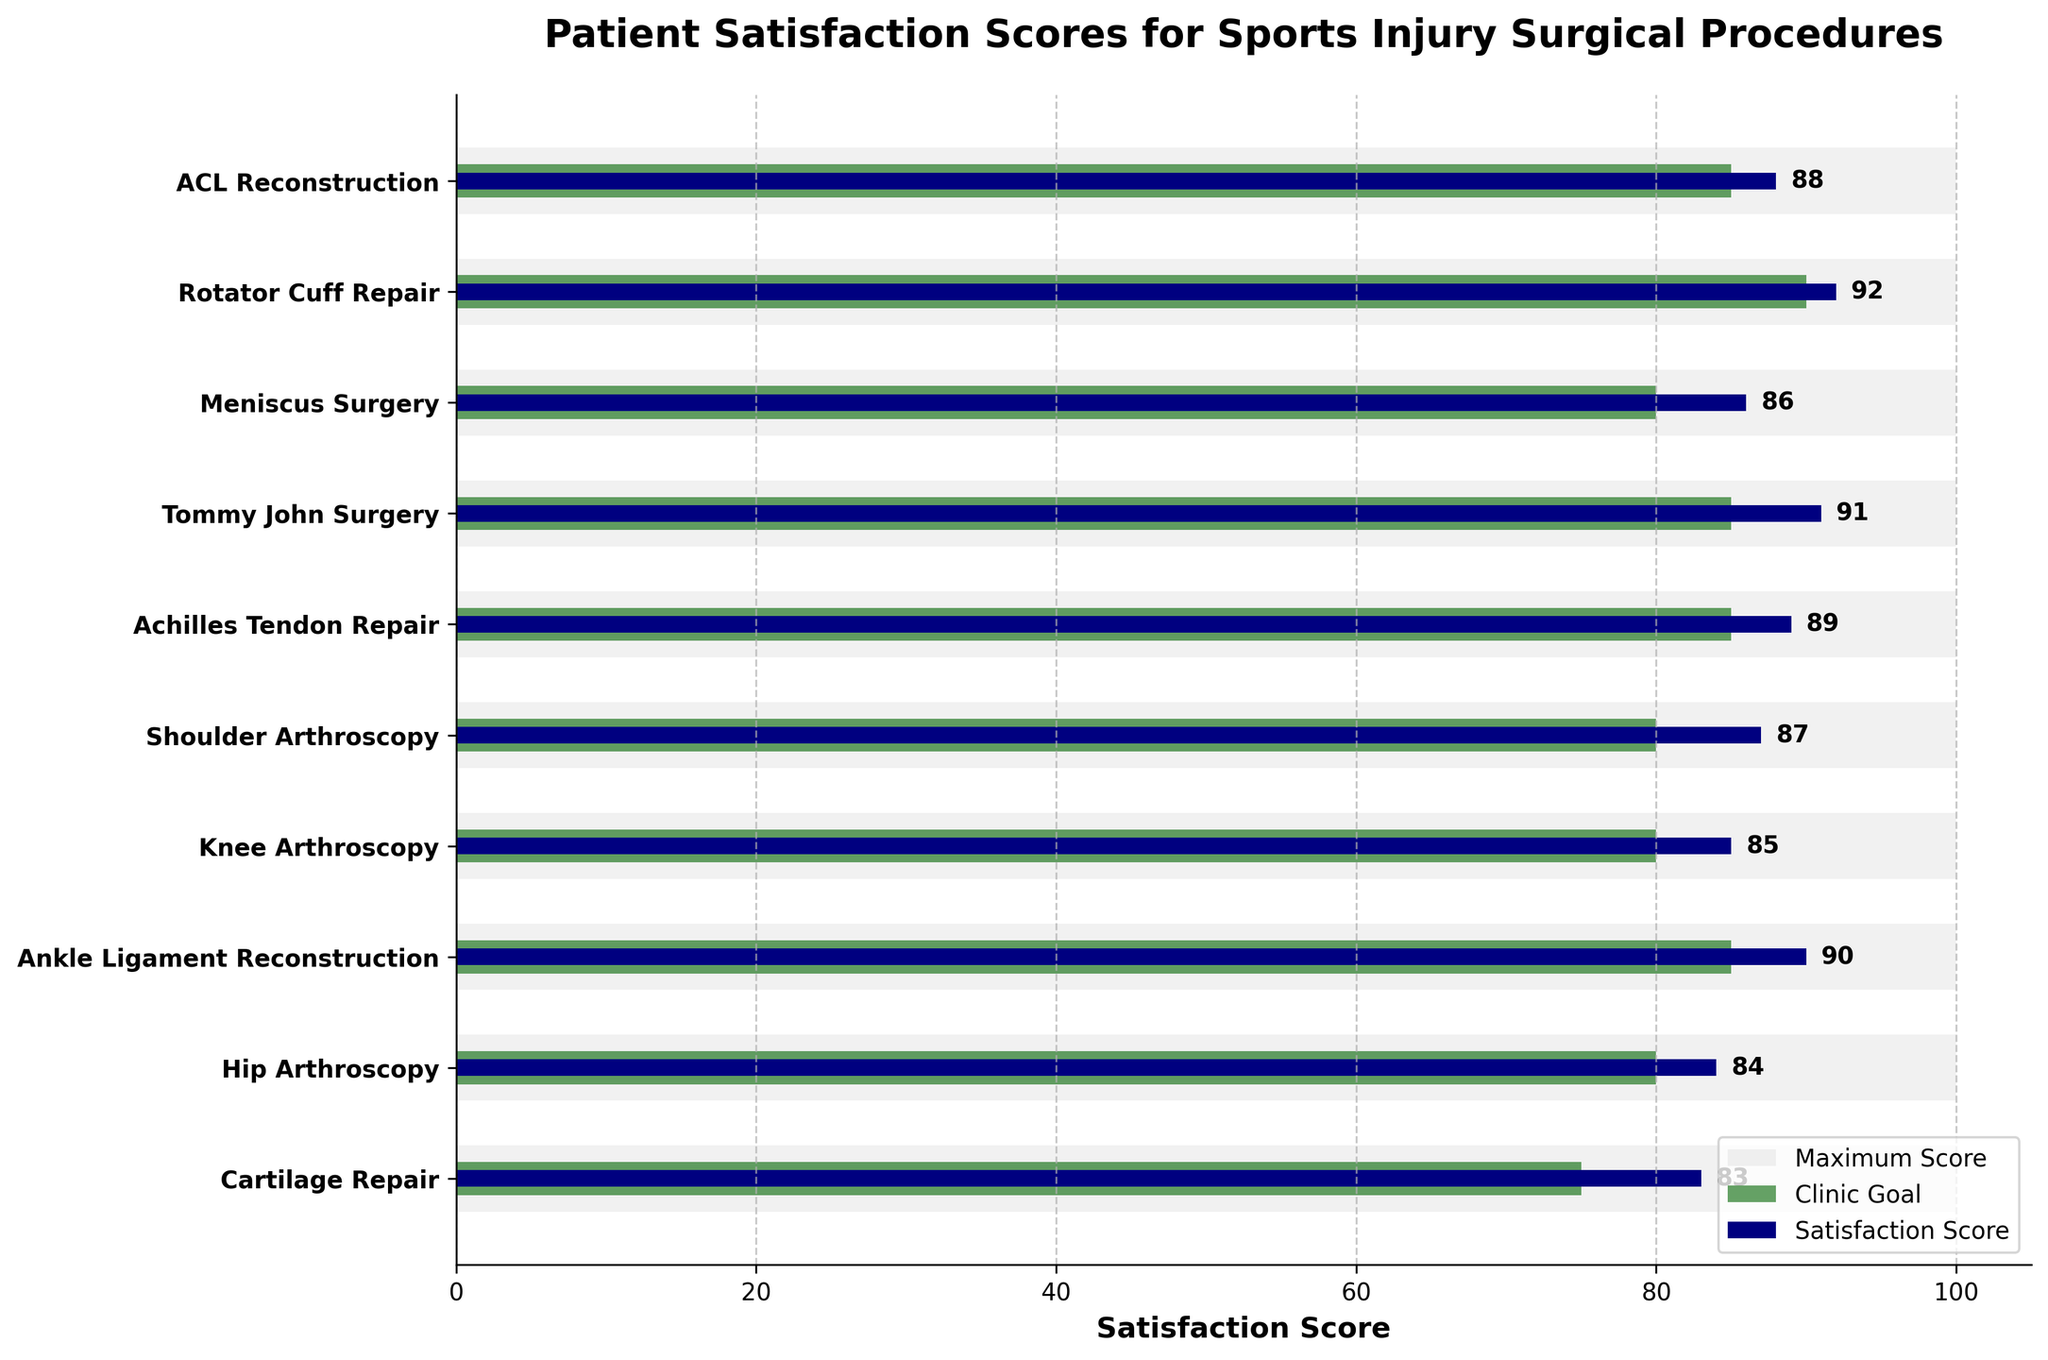How many surgical procedures are listed in the figure? The figure lists 10 procedures: ACL Reconstruction, Rotator Cuff Repair, Meniscus Surgery, Tommy John Surgery, Achilles Tendon Repair, Shoulder Arthroscopy, Knee Arthroscopy, Ankle Ligament Reconstruction, Hip Arthroscopy, and Cartilage Repair.
Answer: 10 Which procedure has the highest patient satisfaction score? The highest patient satisfaction score can be identified by comparing the heights of the bars colored navy blue. Rotator Cuff Repair has the highest score at 92.
Answer: Rotator Cuff Repair Is any procedure's satisfaction score equal to its clinic goal? Check if any of the navy blue bars are exactly the same length as the dark green bars beside them. None of the procedures have their satisfaction scores equal to clinic goals.
Answer: None What is the difference between the satisfaction score and the clinic goal for ACL Reconstruction? Subtract the clinic goal of 85 from the satisfaction score of 88 for ACL Reconstruction. 88 - 85 = 3.
Answer: 3 Which procedure has the least difference between its satisfaction score and clinic goal? Compare the differences between satisfaction scores and clinic goals for all procedures. ACL Reconstruction has the least difference with a difference of 3.
Answer: ACL Reconstruction What is the average satisfaction score for all procedures? Sum all satisfaction scores (88 + 92 + 86 + 91 + 89 + 87 + 85 + 90 + 84 + 83) and divide by the number of procedures (10). The average = 875 / 10 = 87.5.
Answer: 87.5 Between 'ACL Reconstruction' and 'Achilles Tendon Repair,' which procedure has a higher satisfaction score? Compare the satisfaction scores for ACL Reconstruction (88) and Achilles Tendon Repair (89). Achilles Tendon Repair has a higher score.
Answer: Achilles Tendon Repair Do any procedures have a satisfaction score of less than 80? Check if any of the navy blue bars fall below a score of 80. All bars are above 80.
Answer: No What is the range of the satisfaction scores across all procedures? Identify the highest score (92) and the lowest score (83), then subtract the lowest from the highest. The range = 92 - 83 = 9.
Answer: 9 How many procedures have a satisfaction score greater than their clinic goal? Compare the satisfaction scores and clinic goals for all procedures. There are 8 procedures where the satisfaction score is greater than the clinic goal.
Answer: 8 